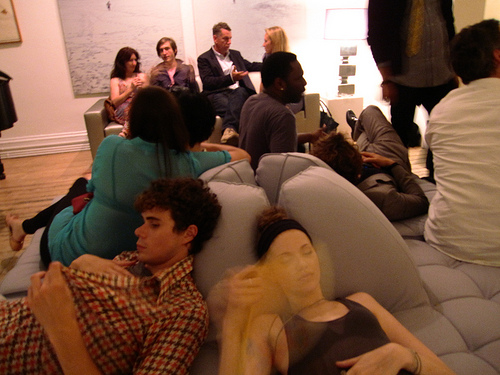<image>
Is there a man above the couch? No. The man is not positioned above the couch. The vertical arrangement shows a different relationship. Where is the man in relation to the woman? Is it behind the woman? No. The man is not behind the woman. From this viewpoint, the man appears to be positioned elsewhere in the scene. 